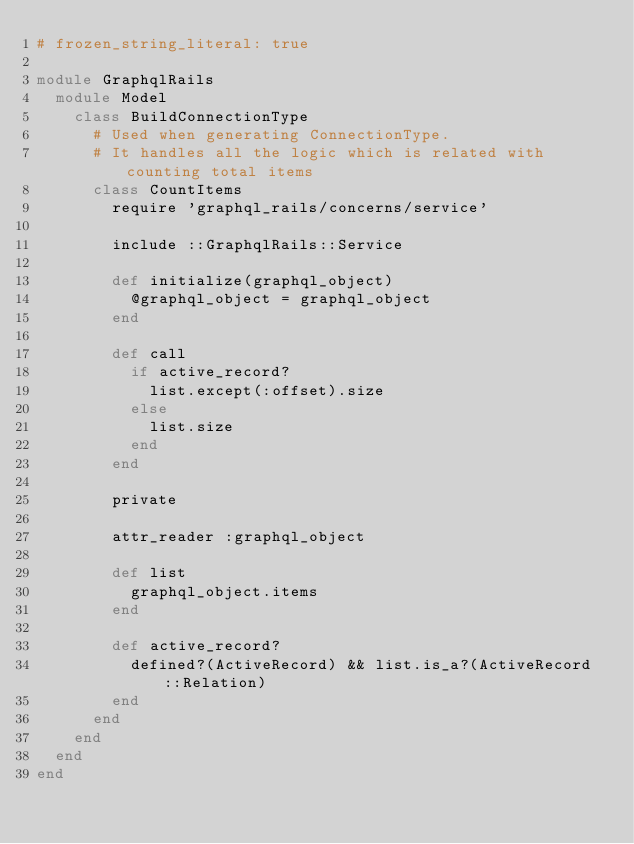<code> <loc_0><loc_0><loc_500><loc_500><_Ruby_># frozen_string_literal: true

module GraphqlRails
  module Model
    class BuildConnectionType
      # Used when generating ConnectionType.
      # It handles all the logic which is related with counting total items
      class CountItems
        require 'graphql_rails/concerns/service'

        include ::GraphqlRails::Service

        def initialize(graphql_object)
          @graphql_object = graphql_object
        end

        def call
          if active_record?
            list.except(:offset).size
          else
            list.size
          end
        end

        private

        attr_reader :graphql_object

        def list
          graphql_object.items
        end

        def active_record?
          defined?(ActiveRecord) && list.is_a?(ActiveRecord::Relation)
        end
      end
    end
  end
end
</code> 